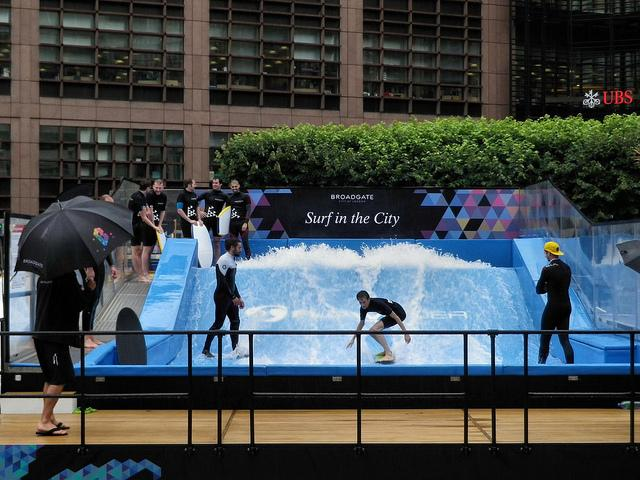What sort of building is seen behind this amusement?

Choices:
A) school
B) barn
C) cafe
D) financial financial 